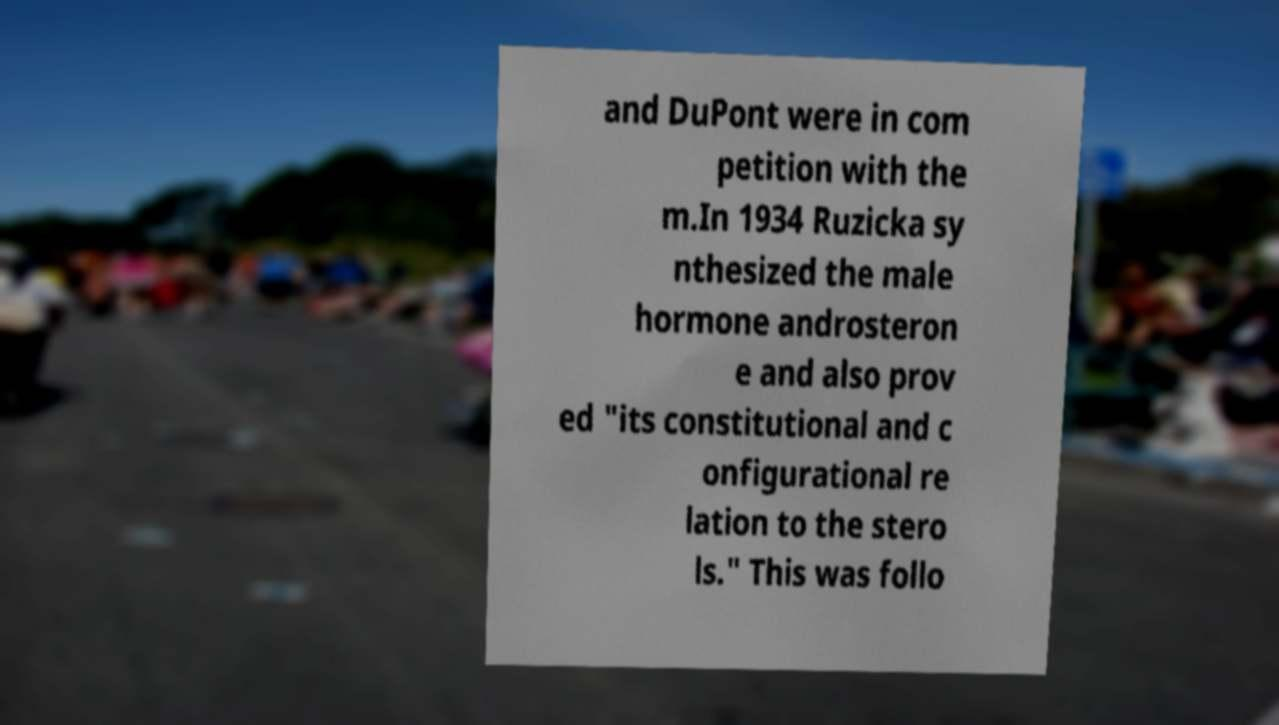Please identify and transcribe the text found in this image. and DuPont were in com petition with the m.In 1934 Ruzicka sy nthesized the male hormone androsteron e and also prov ed "its constitutional and c onfigurational re lation to the stero ls." This was follo 